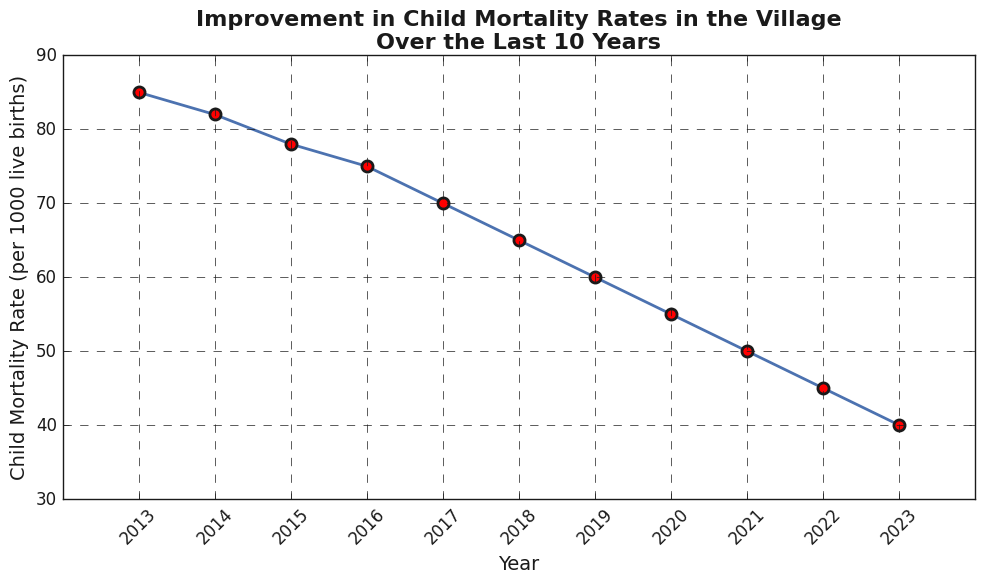Which year had the highest child mortality rate depicted in the figure? Referencing the figure, we see the highest point on the vertical axis corresponding to child mortality rate happens in the year 2013.
Answer: 2013 How much did the child mortality rate decrease from 2013 to 2023? The child mortality rate in 2013 was 85 and in 2023 it was 40. The difference is calculated as 85 - 40 = 45.
Answer: 45 What is the average child mortality rate over the last 10 years? To find the average, sum all the yearly child mortality rates and divide by the number of years: (85 + 82 + 78 + 75 + 70 + 65 + 60 + 55 + 50 + 45 + 40) / 11 = 705 / 11 ≈ 64.09
Answer: 64.09 In which year was there the greatest year-to-year decrease in child mortality rate? We need to calculate the yearly differences and find the maximum decrease: 
2014-2013 = 3, 
2015-2014 = 4, 
2016-2015 = 3, 
2017-2016 = 5, 
2018-2017 = 5, 
2019-2018 = 5, 
2020-2019 = 5, 
2021-2020 = 5, 
2022-2021 = 5, 
2023-2022 = 5. 
The greatest decrease was 5 and it occurred in the years 2017, 2018, 2019, 2020, 2021, 2022, and 2023.
Answer: 2017 (also 2018, 2019, 2020, 2021, 2022, and 2023) What is the median child mortality rate over the last 10 years? First, we list the yearly child mortality rates in ascending order: 40, 45, 50, 55, 60, 65, 70, 75, 78, 82, 85. Since there are 11 data points, the median is the 6th value, which is 65.
Answer: 65 Between which two consecutive years did the child mortality rate remain constant? After examining the data in the figure for years, it is observed that the child mortality rates are always decreasing each year. Therefore, it did not remain constant between any years.
Answer: None Which year showed the smallest improvement (decrease) in child mortality rate compared to the previous year? From the calculated differences between each consecutive year: 2014-2013 = 3, 2015-2014 = 4, 2016-2015 = 3, 2017-2016 = 5, 2018-2017 = 5, 2019-2018 = 5, 2020-2019 = 5, 2021-2020 = 5, 2022-2021 = 5, 2023-2022 = 5. The smallest improvement (3) occurred twice, between 2013-2014 and 2015-2016.
Answer: 2014 and 2016 